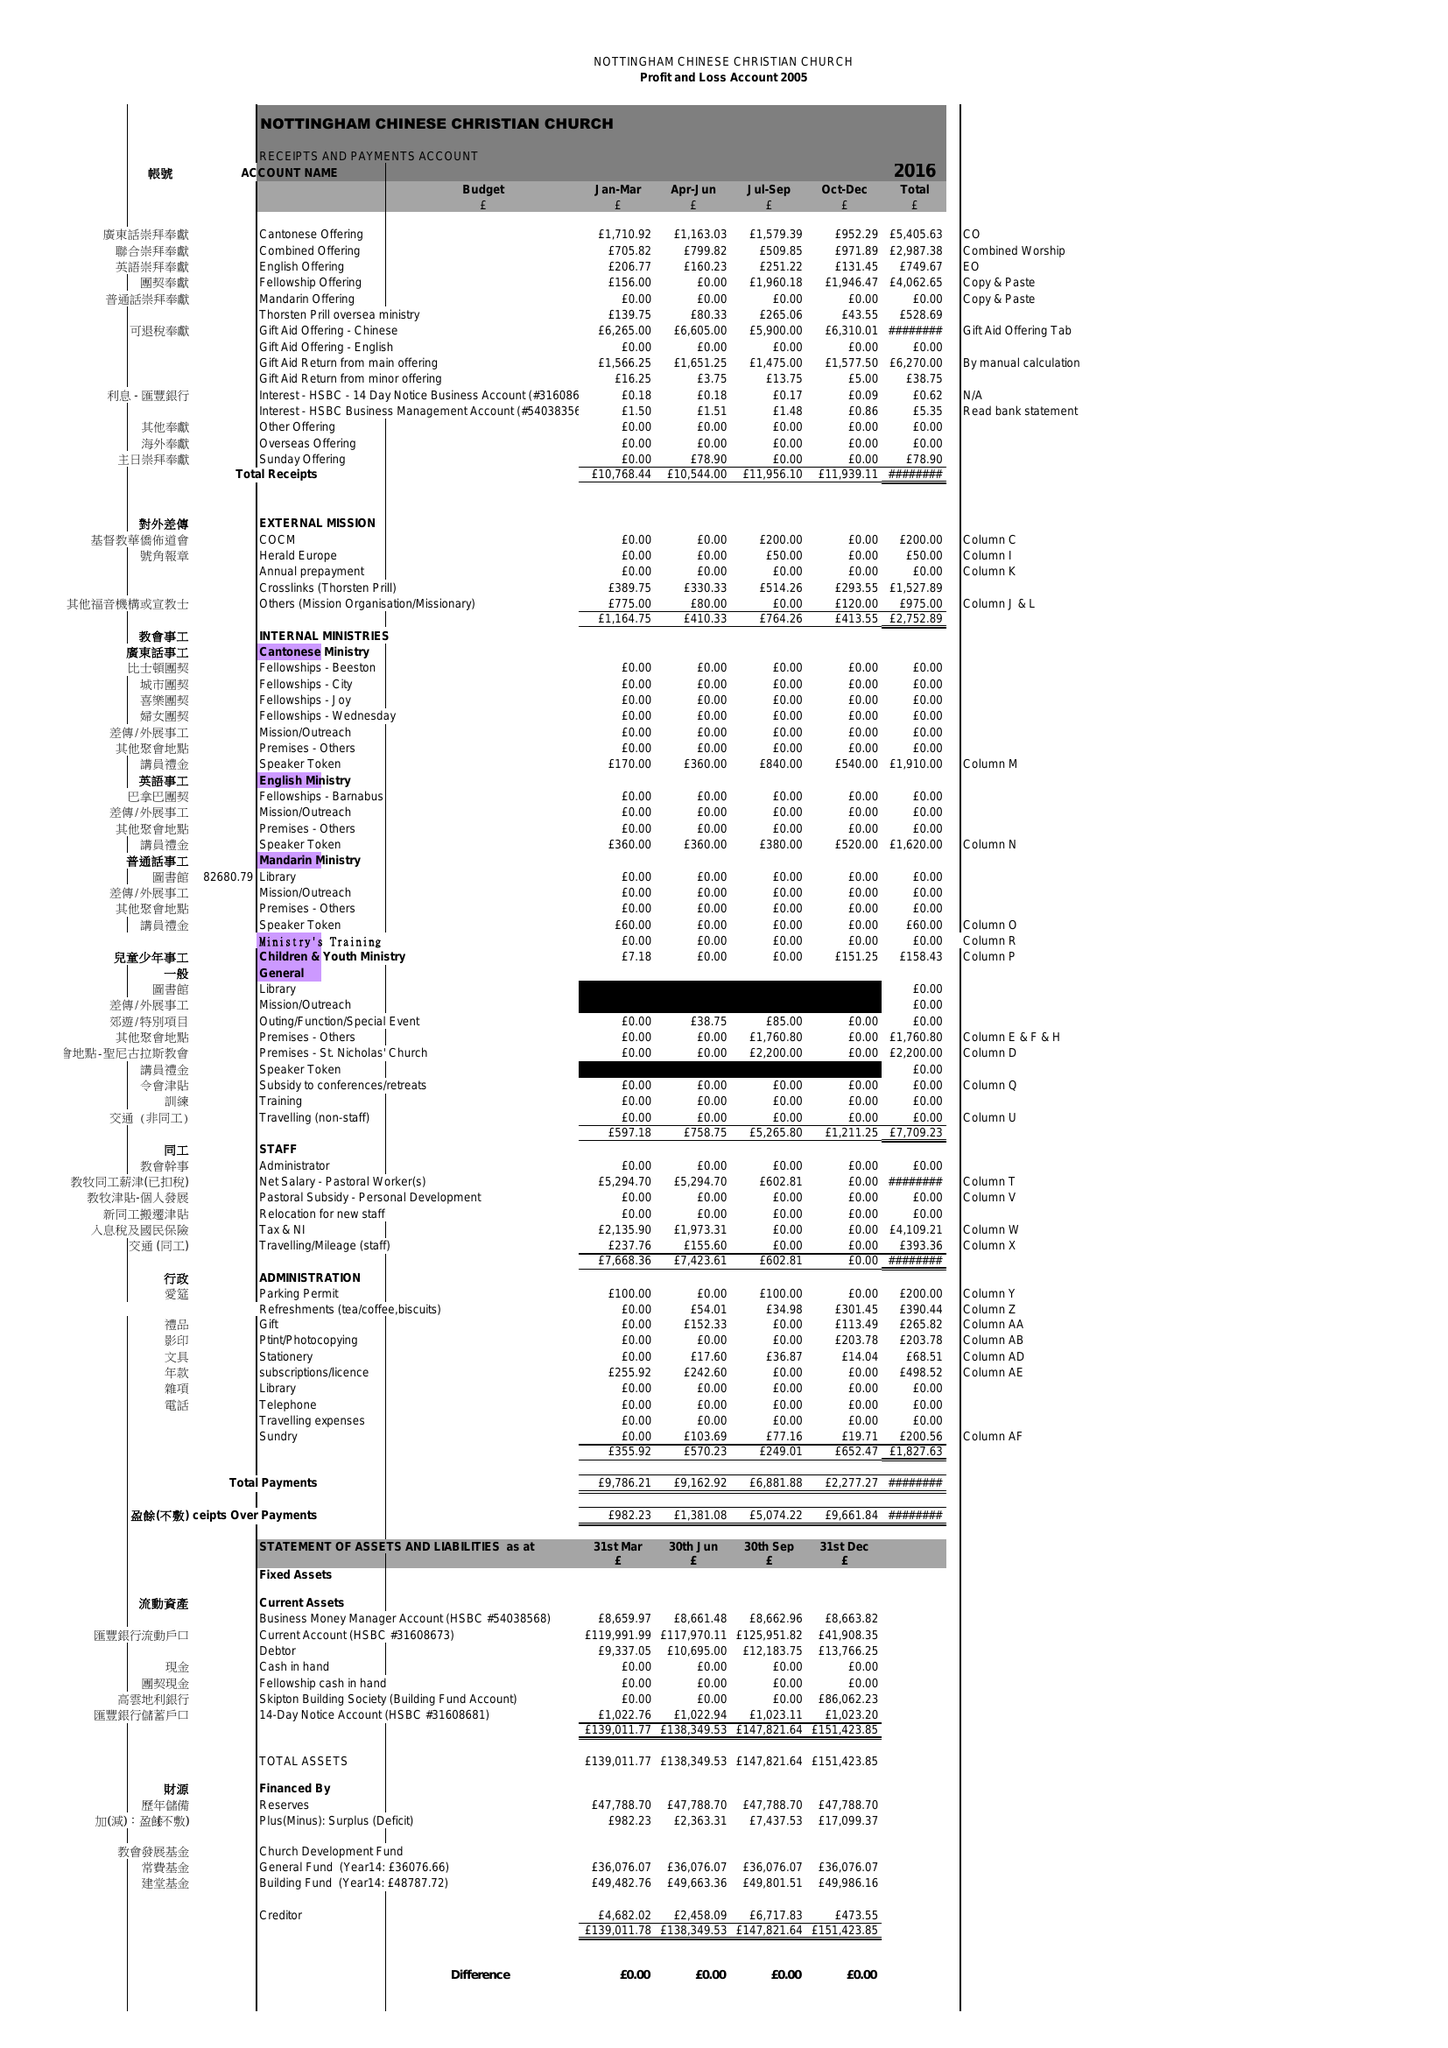What is the value for the address__post_town?
Answer the question using a single word or phrase. NOTTINGHAM 